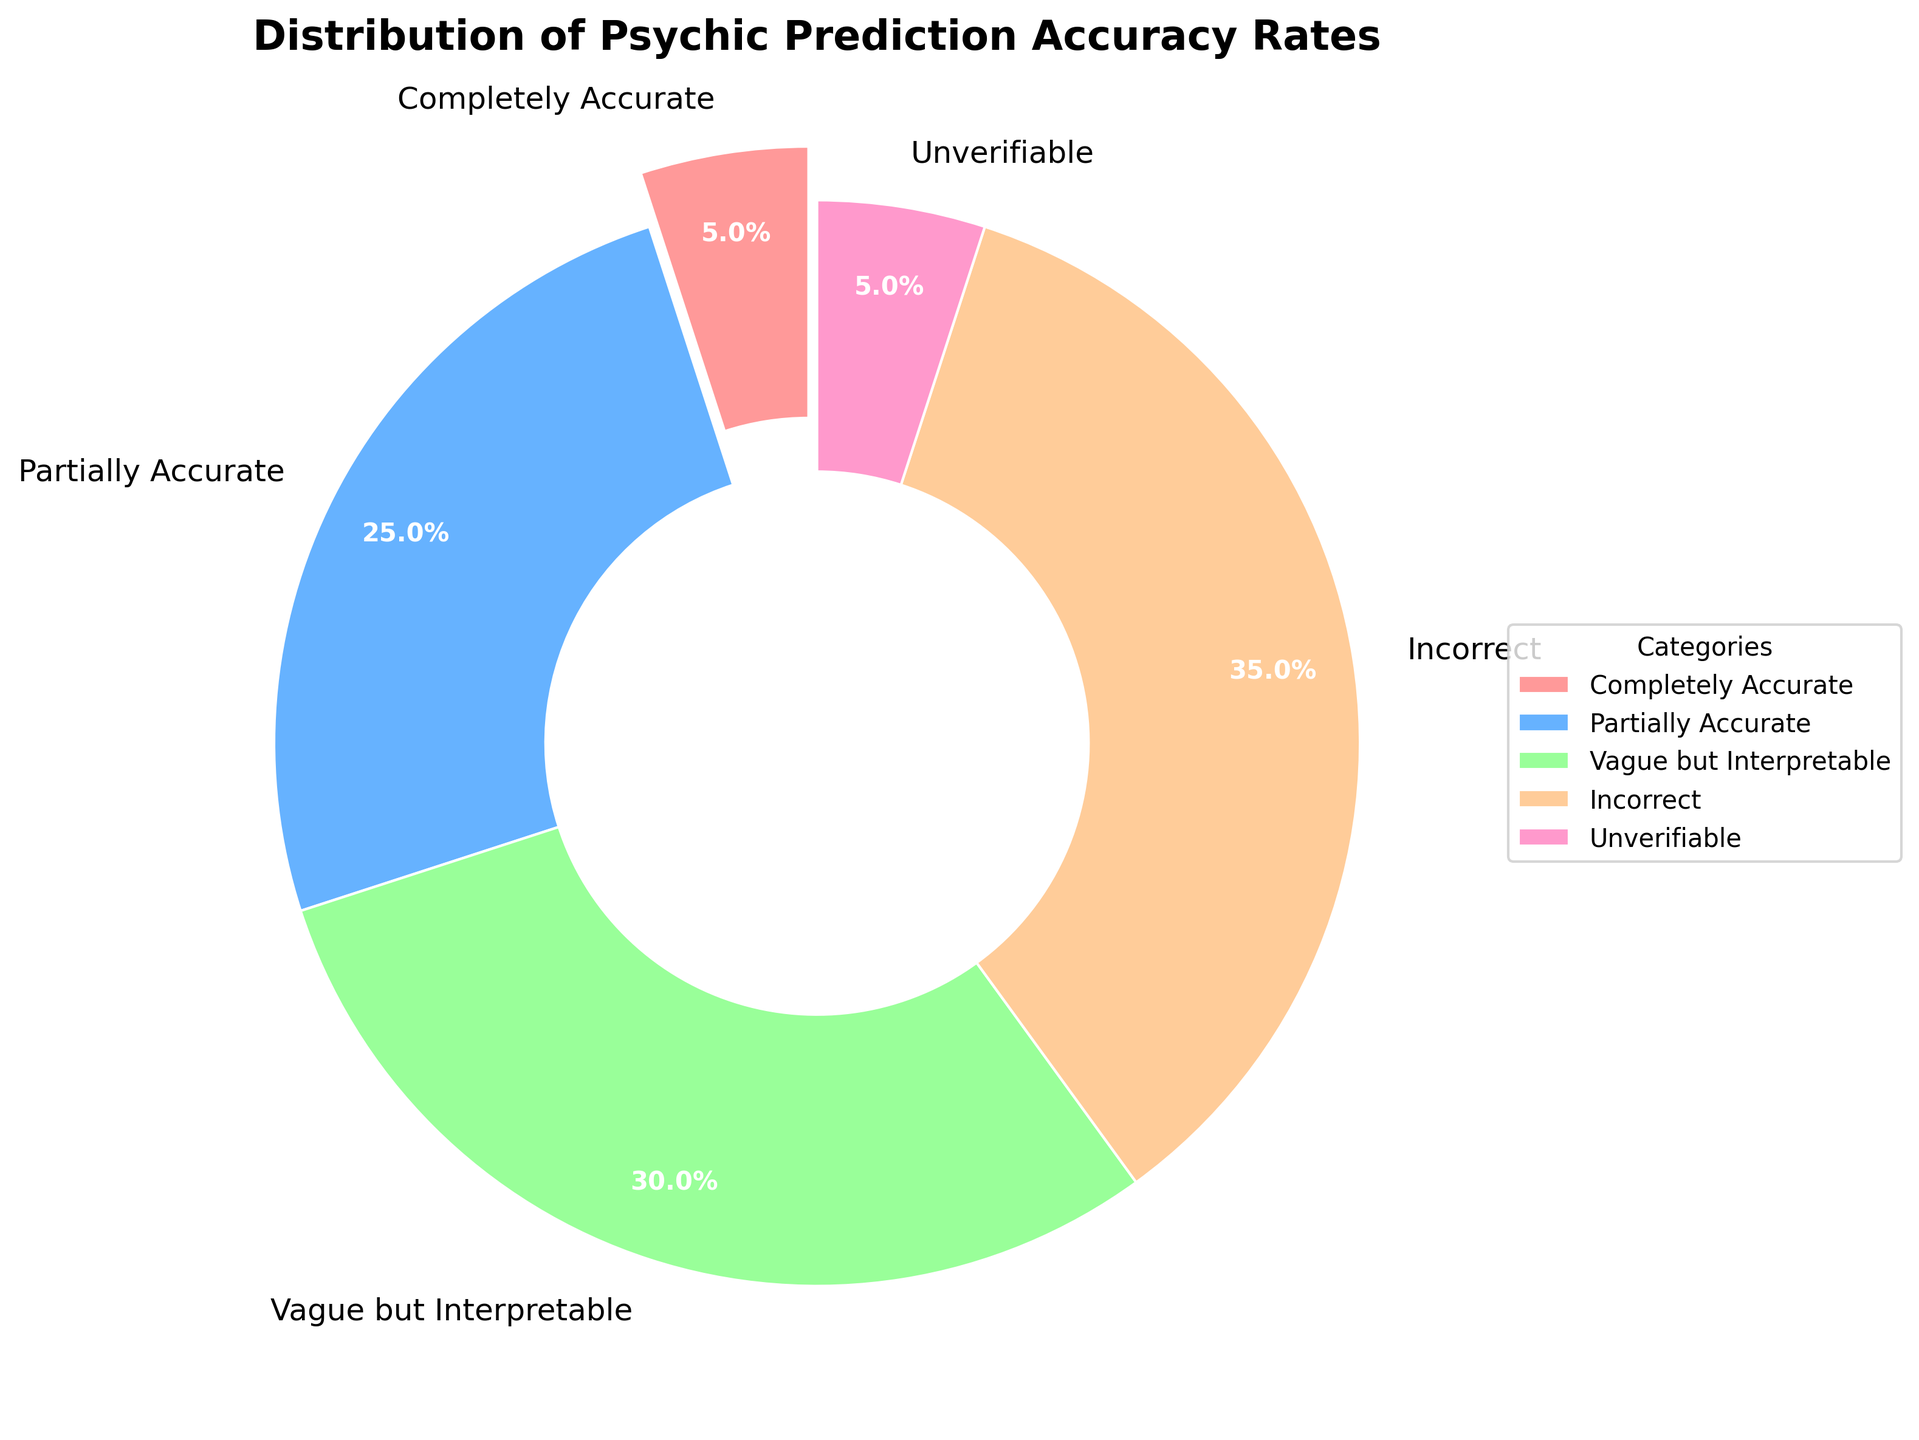What is the largest category in the pie chart? The largest category is identified by looking at the segment with the highest percentage. In this case, it is the “Incorrect” category with 35%.
Answer: Incorrect Which two categories combined make up 60% of the predictions? Adding the percentages of the "Partially Accurate" and "Vague but Interpretable" categories gives: 25% + 30% = 55%. Trying "Incorrect" and "Vague but Interpretable" gives: 35% + 30% = 65%. Therefore, “Partially Accurate” and “Incorrect” gives: 25% + 35% = 60%.
Answer: Partially Accurate and Incorrect What percentage of the predictions are accurate to some extent ("Completely Accurate" and "Partially Accurate" combined)? Add the "Completely Accurate" and "Partially Accurate" percentages: 5% + 25% = 30%.
Answer: 30% Which category has the smallest wedge in the pie chart? The smallest wedge corresponds to the “Completely Accurate” and "Unverifiable" categories, both at 5%.
Answer: Completely Accurate and Unverifiable How much larger is the "Incorrect" category compared to the "Completely Accurate" category? Subtract the "Completely Accurate" percentage from the "Incorrect" percentage: 35% - 5% = 30%.
Answer: 30% What is the ratio of "Partially Accurate" to "Vague but Interpretable"? Divide the "Partially Accurate" percentage by the "Vague but Interpretable" percentage: 25% / 30% = 5:6.
Answer: 5:6 How many categories are more than 30% of the predictions? By checking each percentage, only the "Incorrect" category has more than 30%.
Answer: 1 If you combine the "Completely Accurate", "Partially Accurate", and "Vague but Interpretable" categories, what percentage of predictions does that cover? Add the percentages: 5% + 25% + 30% = 60%.
Answer: 60% What is the second largest category in the pie chart? The second largest category is identified by looking at the percentages. The "Vague but Interpretable" category with 30% is the second largest.
Answer: Vague but Interpretable What is the visual difference between the wedges of "Completely Accurate" and "Unverifiable"? Visually, both "Completely Accurate" and "Unverifiable" categories occupy the same wedge size as both are 5%. Therefore, they have the same visual representation in the pie chart in terms of size.
Answer: Same 